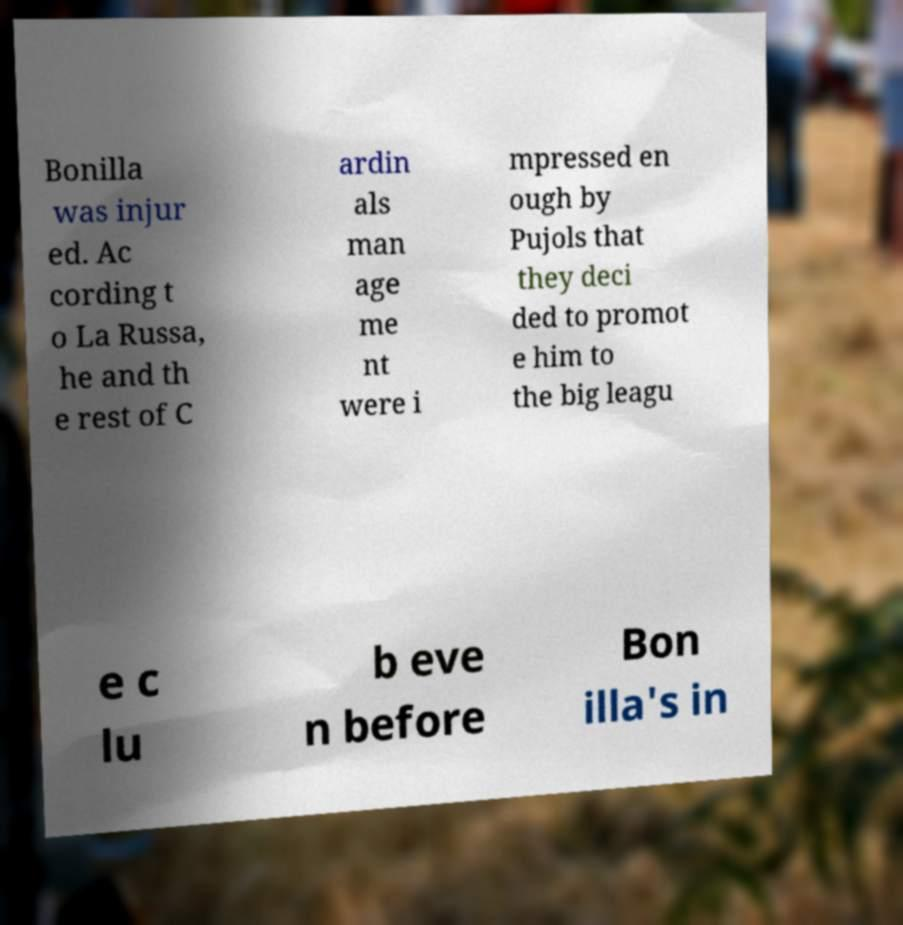Could you extract and type out the text from this image? Bonilla was injur ed. Ac cording t o La Russa, he and th e rest of C ardin als man age me nt were i mpressed en ough by Pujols that they deci ded to promot e him to the big leagu e c lu b eve n before Bon illa's in 